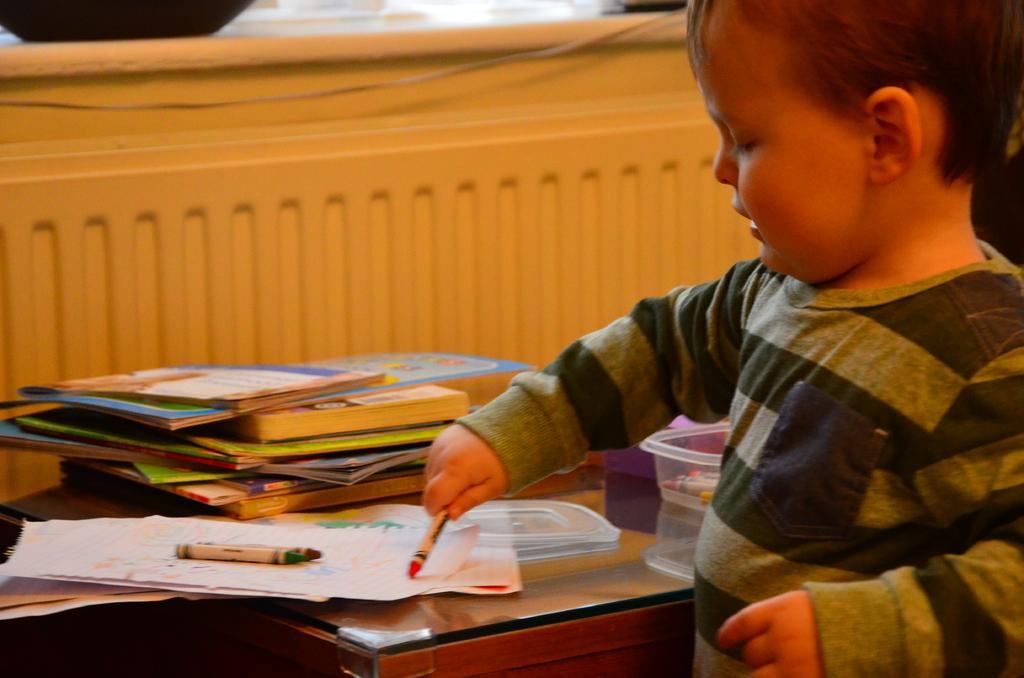Who is the main subject in the image? There is a boy in the image. What is the boy doing in the image? The boy is playing with crayons. What is the location of the boy in the image? The boy is likely sitting at a table, as there is a table in the image. What else can be seen on the table? There are books and a box on the table. What is visible in the background of the image? There is a wall in the image. What type of bird can be seen flying over the boy's head in the image? There is no bird visible in the image; it only features a boy playing with crayons, a table, books, a box, and a wall. 